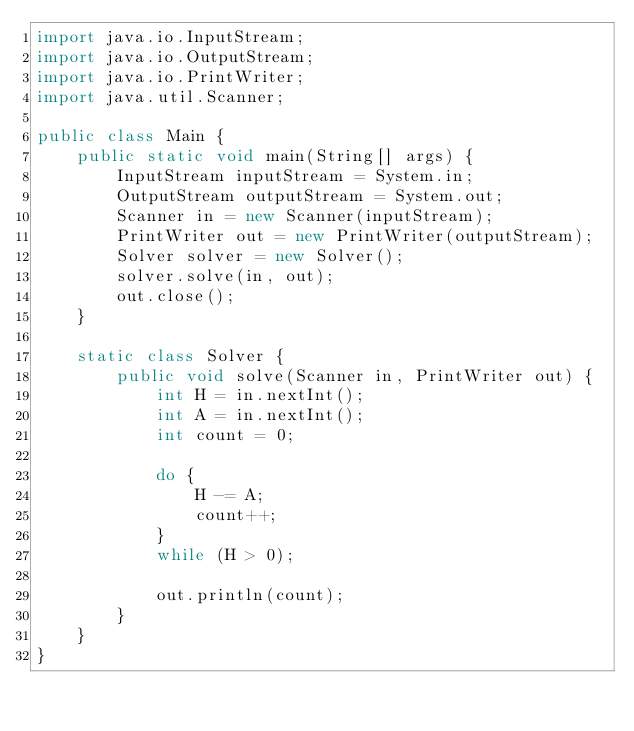Convert code to text. <code><loc_0><loc_0><loc_500><loc_500><_Java_>import java.io.InputStream;
import java.io.OutputStream;
import java.io.PrintWriter;
import java.util.Scanner;

public class Main {
    public static void main(String[] args) {
        InputStream inputStream = System.in;
        OutputStream outputStream = System.out;
        Scanner in = new Scanner(inputStream);
        PrintWriter out = new PrintWriter(outputStream);
        Solver solver = new Solver();
        solver.solve(in, out);
        out.close();
    }

    static class Solver {
        public void solve(Scanner in, PrintWriter out) {
            int H = in.nextInt();
            int A = in.nextInt();
            int count = 0;

            do {
                H -= A;
                count++;
            }
            while (H > 0);

            out.println(count);
        }
    }
}</code> 